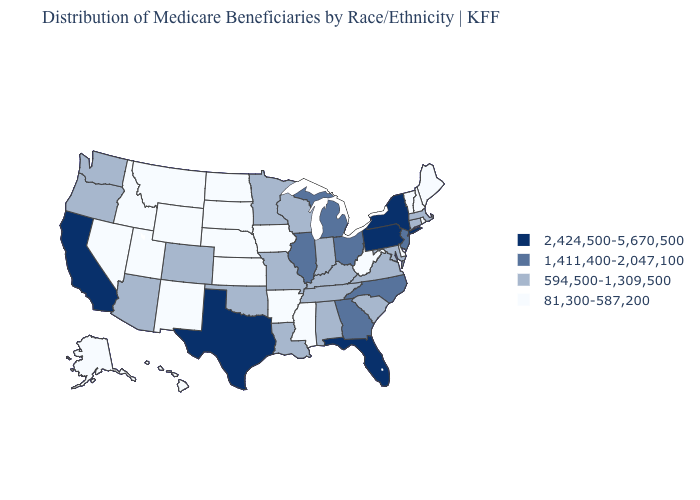What is the value of Illinois?
Write a very short answer. 1,411,400-2,047,100. What is the value of Louisiana?
Give a very brief answer. 594,500-1,309,500. Name the states that have a value in the range 2,424,500-5,670,500?
Write a very short answer. California, Florida, New York, Pennsylvania, Texas. What is the lowest value in the USA?
Keep it brief. 81,300-587,200. Name the states that have a value in the range 1,411,400-2,047,100?
Quick response, please. Georgia, Illinois, Michigan, New Jersey, North Carolina, Ohio. Does Iowa have the highest value in the MidWest?
Write a very short answer. No. What is the value of Washington?
Be succinct. 594,500-1,309,500. Does Michigan have the lowest value in the USA?
Quick response, please. No. What is the value of Rhode Island?
Quick response, please. 81,300-587,200. Is the legend a continuous bar?
Answer briefly. No. What is the value of Nebraska?
Be succinct. 81,300-587,200. What is the lowest value in the Northeast?
Write a very short answer. 81,300-587,200. What is the lowest value in the West?
Give a very brief answer. 81,300-587,200. Name the states that have a value in the range 2,424,500-5,670,500?
Be succinct. California, Florida, New York, Pennsylvania, Texas. What is the value of Arkansas?
Answer briefly. 81,300-587,200. 